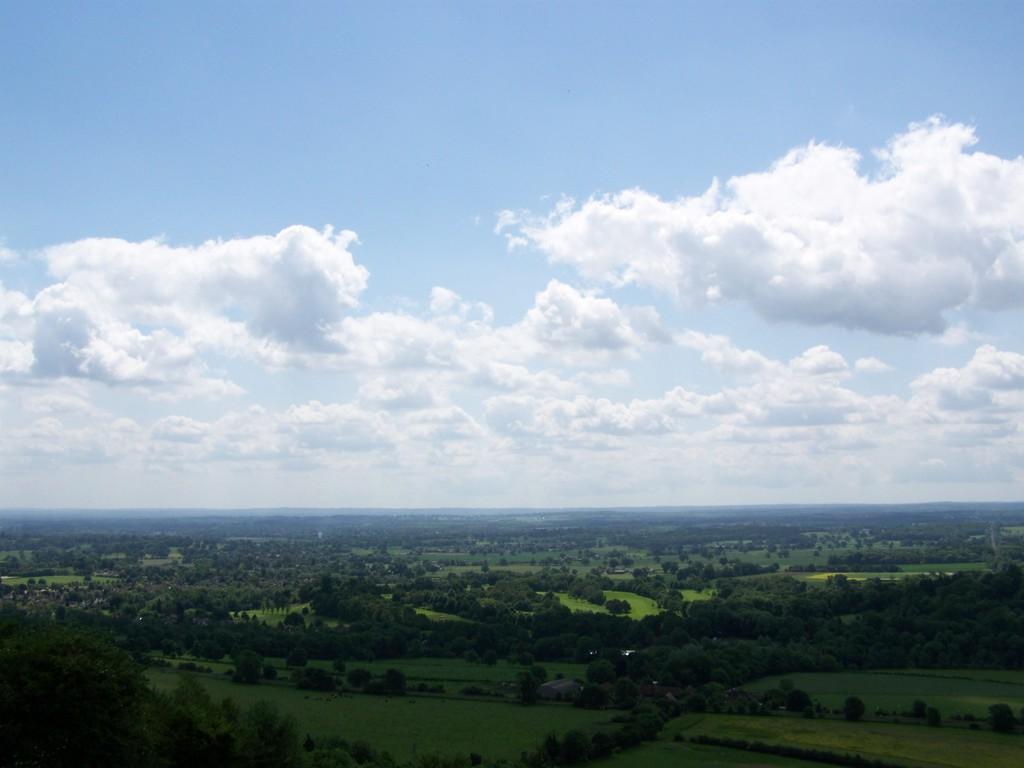Can you describe this image briefly? Here in this picture we can see an aerial view and we can see the ground is fully covered with grass, plants and trees and we can see clouds in the sky. 